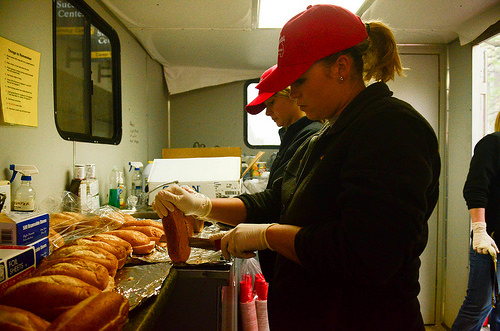<image>
Is the knife next to the bun? Yes. The knife is positioned adjacent to the bun, located nearby in the same general area. Is the woman in front of the other woman? No. The woman is not in front of the other woman. The spatial positioning shows a different relationship between these objects. 